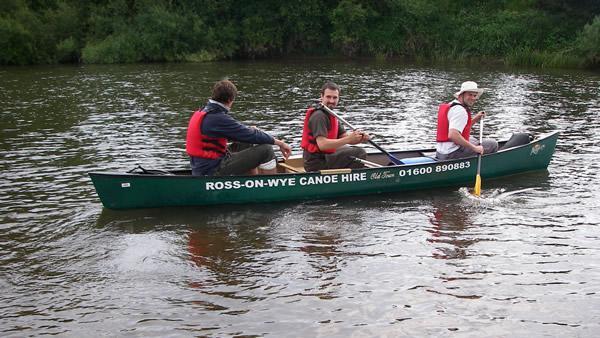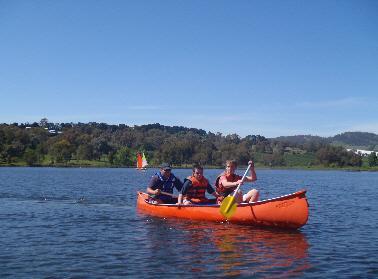The first image is the image on the left, the second image is the image on the right. Given the left and right images, does the statement "Each canoe has three people sitting in them and at least two of those people have an oar." hold true? Answer yes or no. Yes. 